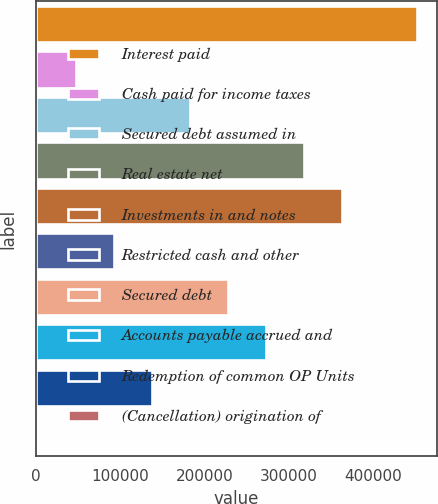Convert chart. <chart><loc_0><loc_0><loc_500><loc_500><bar_chart><fcel>Interest paid<fcel>Cash paid for income taxes<fcel>Secured debt assumed in<fcel>Real estate net<fcel>Investments in and notes<fcel>Restricted cash and other<fcel>Secured debt<fcel>Accounts payable accrued and<fcel>Redemption of common OP Units<fcel>(Cancellation) origination of<nl><fcel>452324<fcel>47379.8<fcel>182361<fcel>317343<fcel>362336<fcel>92373.6<fcel>227355<fcel>272349<fcel>137367<fcel>2386<nl></chart> 